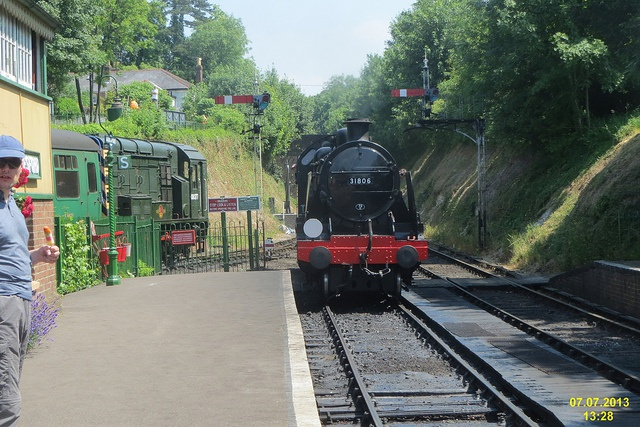Describe the objects in this image and their specific colors. I can see train in gray, black, maroon, and blue tones, train in gray, black, darkgray, and teal tones, and people in gray, darkgray, and lightblue tones in this image. 